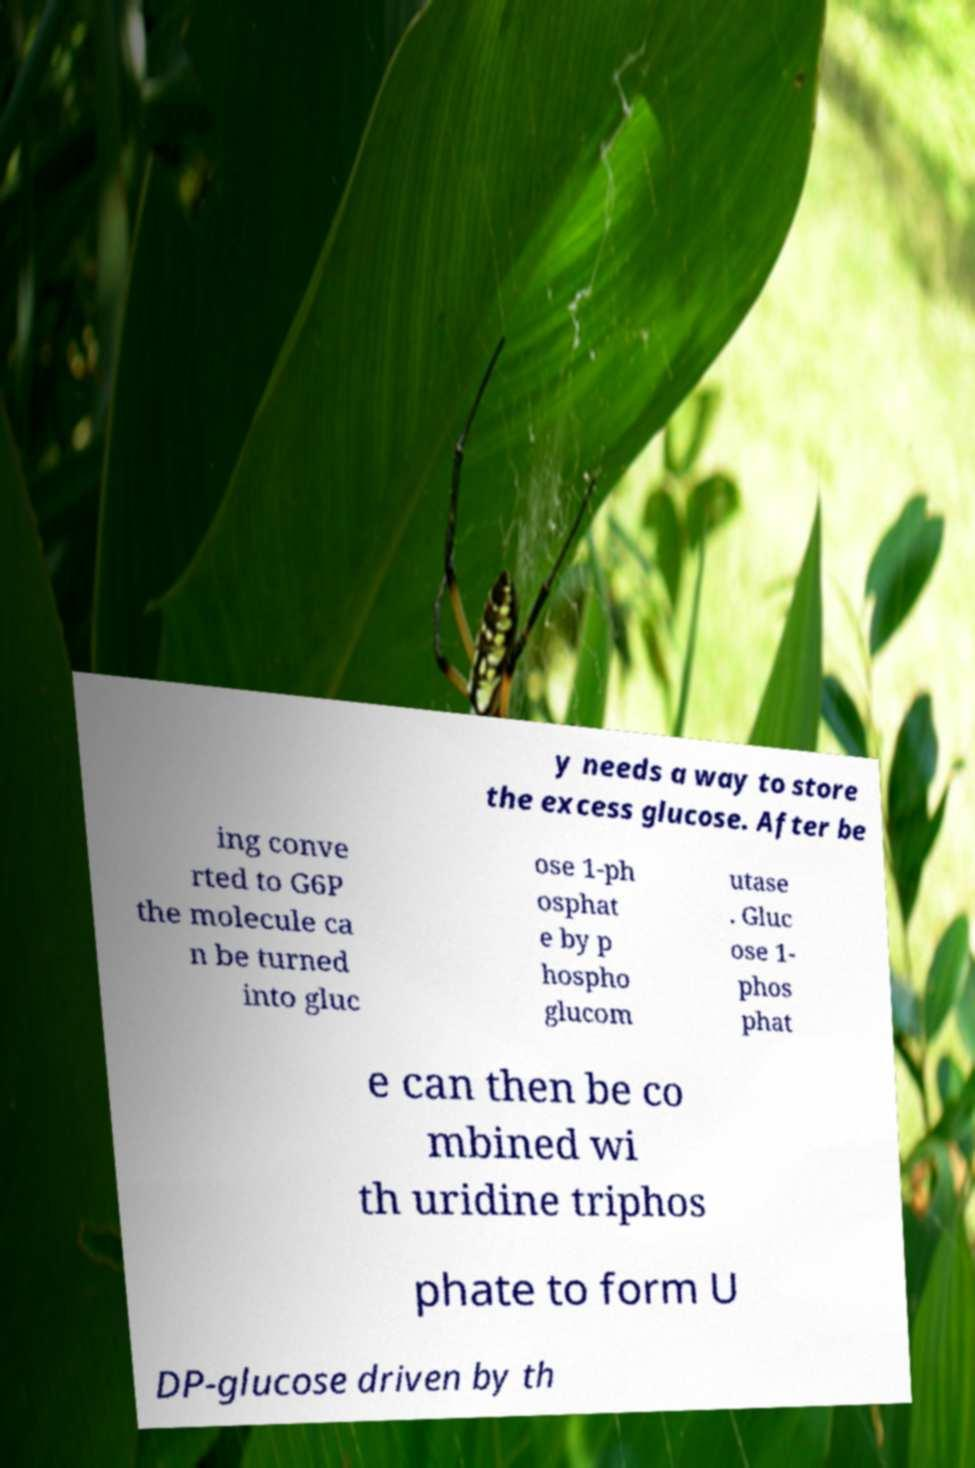Can you accurately transcribe the text from the provided image for me? y needs a way to store the excess glucose. After be ing conve rted to G6P the molecule ca n be turned into gluc ose 1-ph osphat e by p hospho glucom utase . Gluc ose 1- phos phat e can then be co mbined wi th uridine triphos phate to form U DP-glucose driven by th 